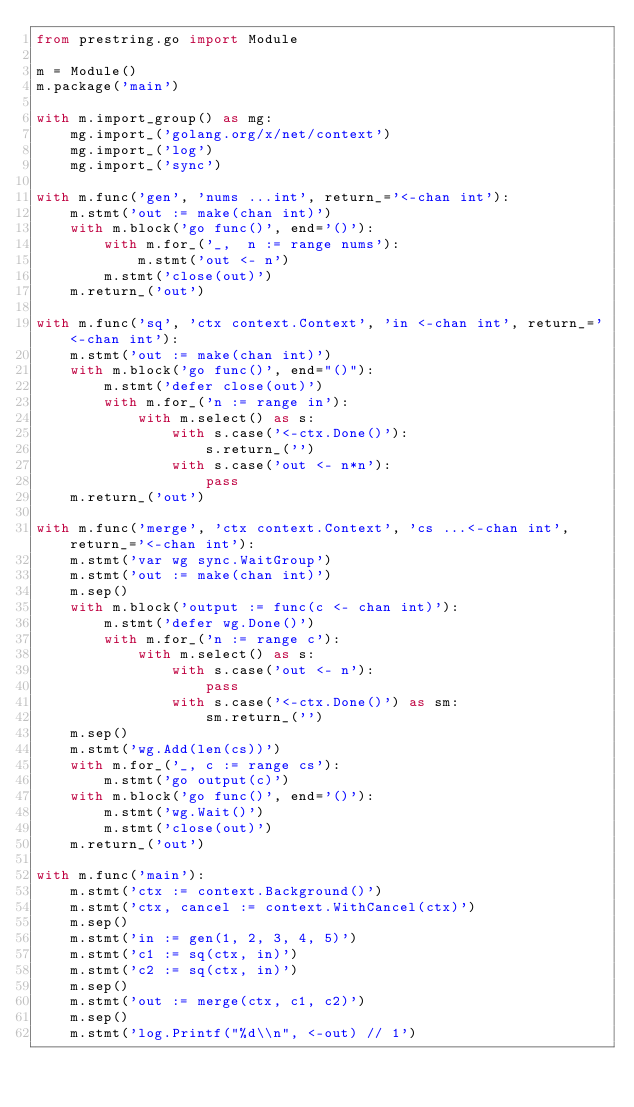<code> <loc_0><loc_0><loc_500><loc_500><_Python_>from prestring.go import Module

m = Module()
m.package('main')

with m.import_group() as mg:
    mg.import_('golang.org/x/net/context')
    mg.import_('log')
    mg.import_('sync')

with m.func('gen', 'nums ...int', return_='<-chan int'):
    m.stmt('out := make(chan int)')
    with m.block('go func()', end='()'):
        with m.for_('_,  n := range nums'):
            m.stmt('out <- n')
        m.stmt('close(out)')
    m.return_('out')

with m.func('sq', 'ctx context.Context', 'in <-chan int', return_='<-chan int'):
    m.stmt('out := make(chan int)')
    with m.block('go func()', end="()"):
        m.stmt('defer close(out)')
        with m.for_('n := range in'):
            with m.select() as s:
                with s.case('<-ctx.Done()'):
                    s.return_('')
                with s.case('out <- n*n'):
                    pass
    m.return_('out')

with m.func('merge', 'ctx context.Context', 'cs ...<-chan int', return_='<-chan int'):
    m.stmt('var wg sync.WaitGroup')
    m.stmt('out := make(chan int)')
    m.sep()
    with m.block('output := func(c <- chan int)'):
        m.stmt('defer wg.Done()')
        with m.for_('n := range c'):
            with m.select() as s:
                with s.case('out <- n'):
                    pass
                with s.case('<-ctx.Done()') as sm:
                    sm.return_('')
    m.sep()
    m.stmt('wg.Add(len(cs))')
    with m.for_('_, c := range cs'):
        m.stmt('go output(c)')
    with m.block('go func()', end='()'):
        m.stmt('wg.Wait()')
        m.stmt('close(out)')
    m.return_('out')

with m.func('main'):
    m.stmt('ctx := context.Background()')
    m.stmt('ctx, cancel := context.WithCancel(ctx)')
    m.sep()
    m.stmt('in := gen(1, 2, 3, 4, 5)')
    m.stmt('c1 := sq(ctx, in)')
    m.stmt('c2 := sq(ctx, in)')
    m.sep()
    m.stmt('out := merge(ctx, c1, c2)')
    m.sep()
    m.stmt('log.Printf("%d\\n", <-out) // 1')</code> 